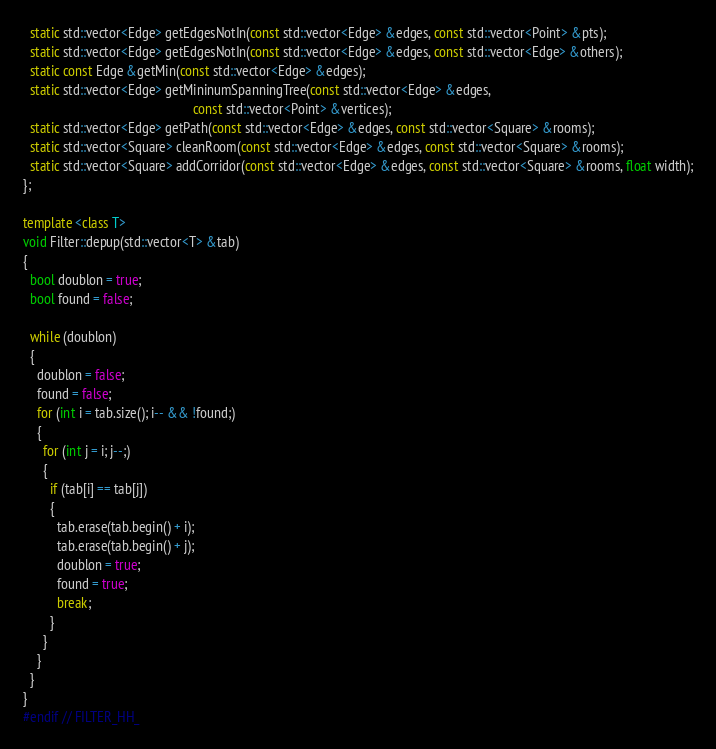<code> <loc_0><loc_0><loc_500><loc_500><_C++_>  static std::vector<Edge> getEdgesNotIn(const std::vector<Edge> &edges, const std::vector<Point> &pts);
  static std::vector<Edge> getEdgesNotIn(const std::vector<Edge> &edges, const std::vector<Edge> &others);
  static const Edge &getMin(const std::vector<Edge> &edges);
  static std::vector<Edge> getMininumSpanningTree(const std::vector<Edge> &edges,
                                                  const std::vector<Point> &vertices);
  static std::vector<Edge> getPath(const std::vector<Edge> &edges, const std::vector<Square> &rooms);
  static std::vector<Square> cleanRoom(const std::vector<Edge> &edges, const std::vector<Square> &rooms);
  static std::vector<Square> addCorridor(const std::vector<Edge> &edges, const std::vector<Square> &rooms, float width);
};

template <class T>
void Filter::depup(std::vector<T> &tab)
{
  bool doublon = true;
  bool found = false;

  while (doublon)
  {
    doublon = false;
    found = false;
    for (int i = tab.size(); i-- && !found;)
    {
      for (int j = i; j--;)
      {
        if (tab[i] == tab[j])
        {
          tab.erase(tab.begin() + i);
          tab.erase(tab.begin() + j);
          doublon = true;
          found = true;
          break;
        }
      }
    }
  }
}
#endif // FILTER_HH_
</code> 